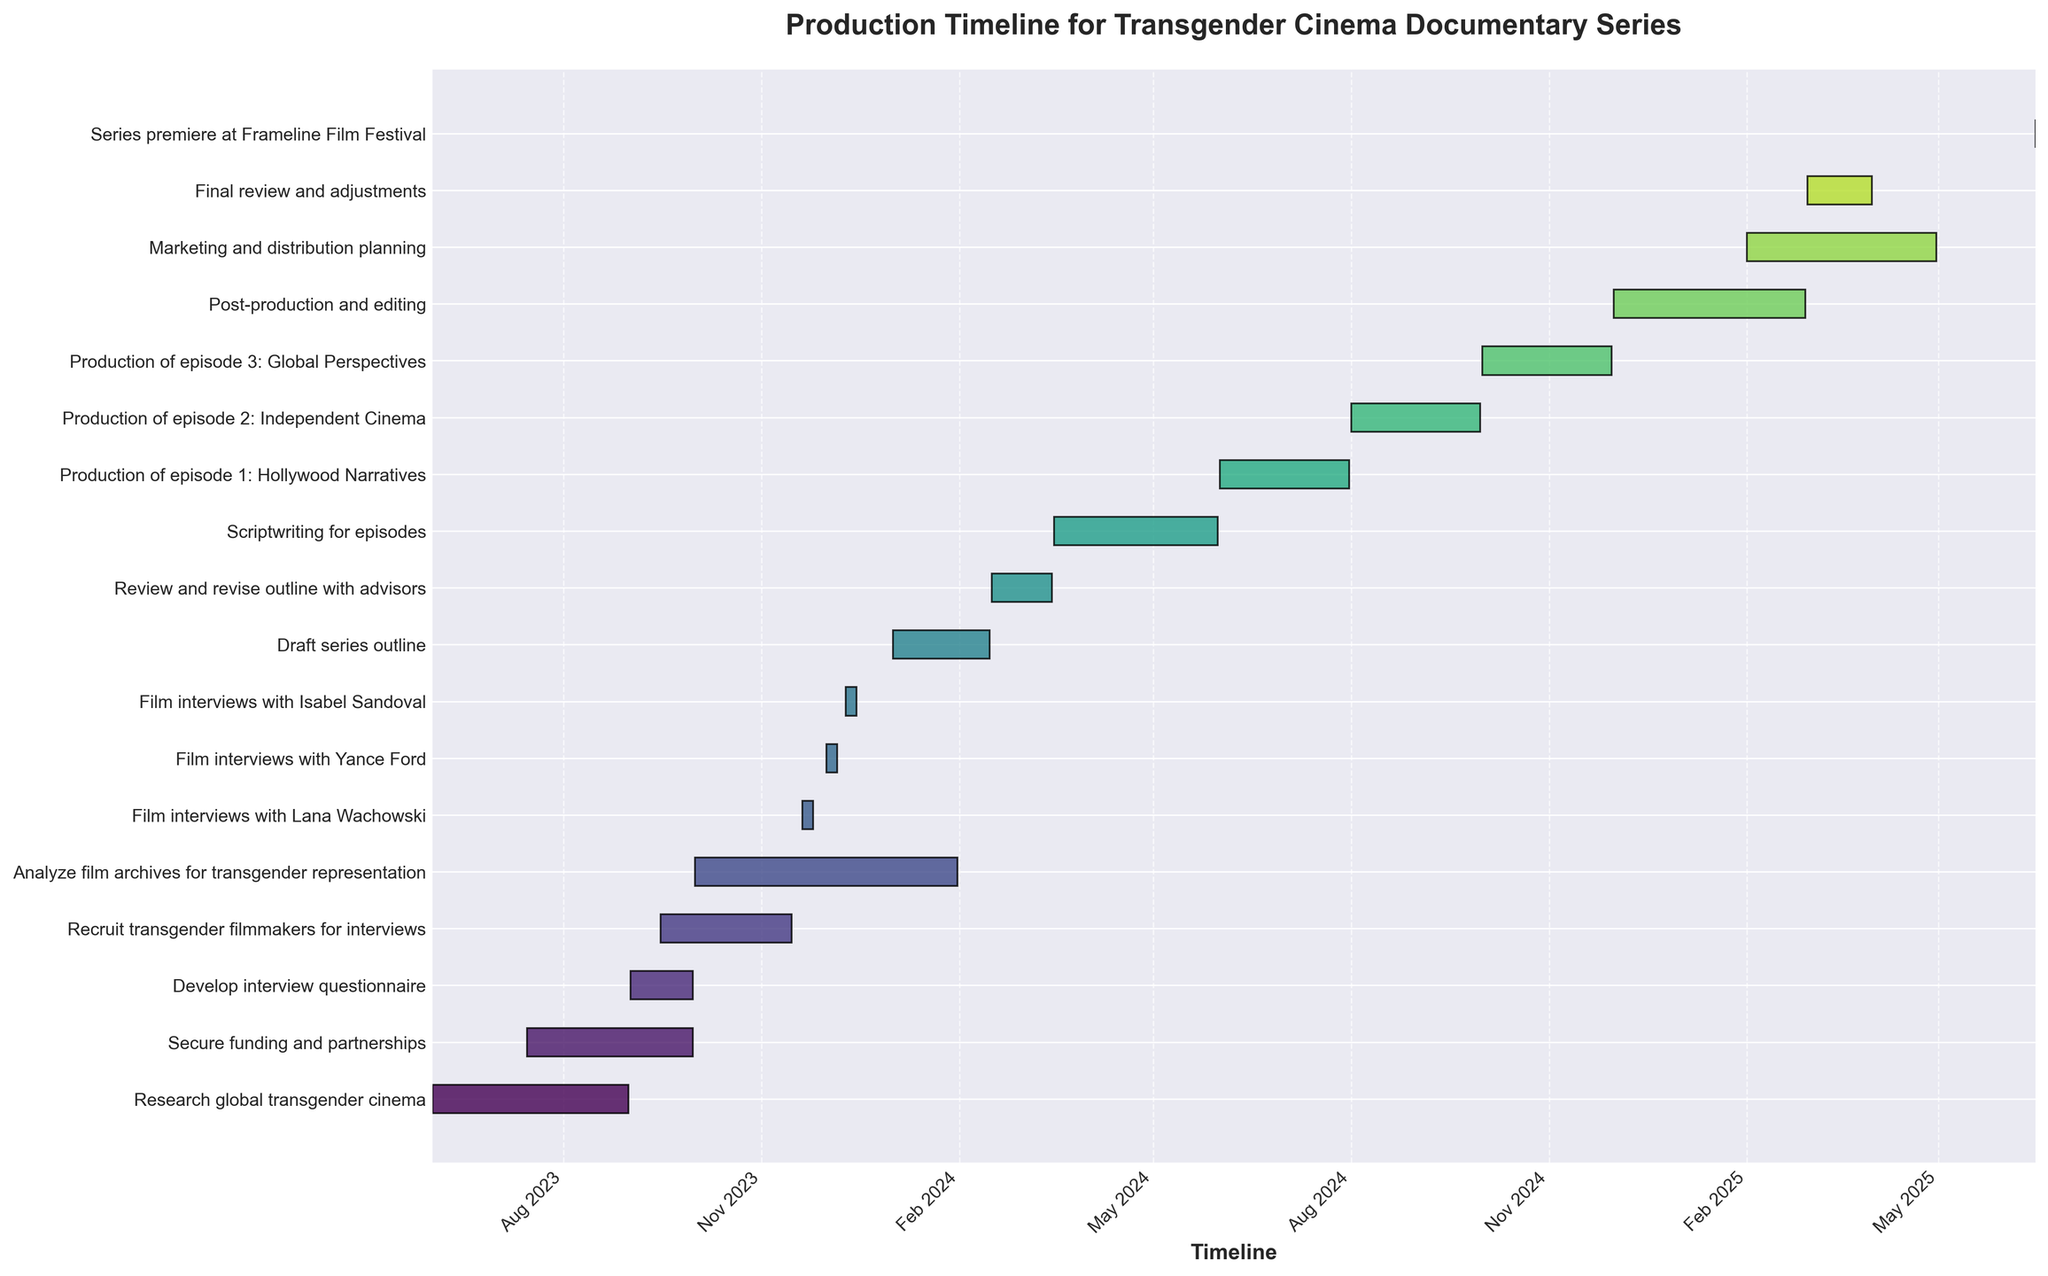What is the title of the Gantt Chart? The title is usually found at the top of the chart, and in this case, it should clearly label the figure.
Answer: Production Timeline for Transgender Cinema Documentary Series What task takes place entirely in December 2023? Look for bars that start and end within the range of December 2023. The task that falls entirely within this month is the one you are looking for.
Answer: Film interviews with Yance Ford Which task has the longest duration? Review the lengths of the bars for each task, since the length indicates the duration. The task with the longest bar is the answer.
Answer: Analyze film archives for transgender representation How many tasks are scheduled to start in 2025? Check the starting dates of each task and count those that begin in the year 2025.
Answer: 3 Which task ends the latest? Identify the tasks with end dates close to each other and find the one that ends the latest in the timeline.
Answer: Marketing and distribution planning What is the total duration from the start of "Develop interview questionnaire" to the end of "Scriptwriting for episodes"? First, find the start date of "Develop interview questionnaire" and note it. Then find the end date of "Scriptwriting for episodes." Calculate the total duration between these dates.
Answer: Approximately 9 months Compare the start and end dates of "Film interviews with Lana Wachowski" and "Film interviews with Isabel Sandoval." Which task is shorter? Find the duration of each task by calculating the difference between the start and end dates. Compare the two durations to determine the shorter task.
Answer: Film interviews with Lana Wachowski Which task overlaps with "Recruit transgender filmmakers for interviews"? Identify the period in which "Recruit transgender filmmakers for interviews" takes place and find any other tasks that have bars overlapping this time period.
Answer: Develop interview questionnaire, Analyze film archives for transgender representation In which month does the series premiere occur? Look for the task labeled "Series premiere at Frameline Film Festival" and note the date associated with it.
Answer: June 2025 How many tasks overlap in November 2023? Identify all tasks that have parts of their bars in November 2023 and count them.
Answer: 2 